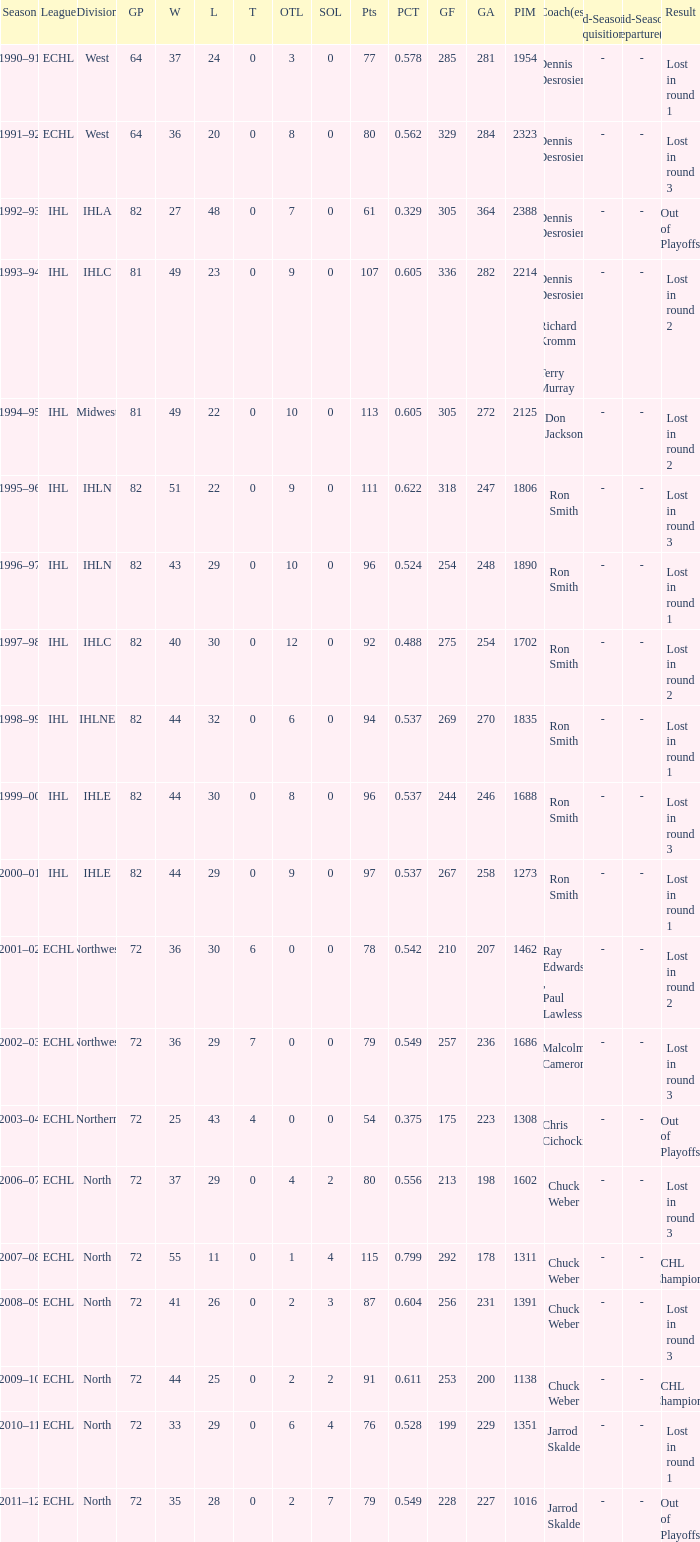How many season did the team lost in round 1 with a GP of 64? 1.0. 